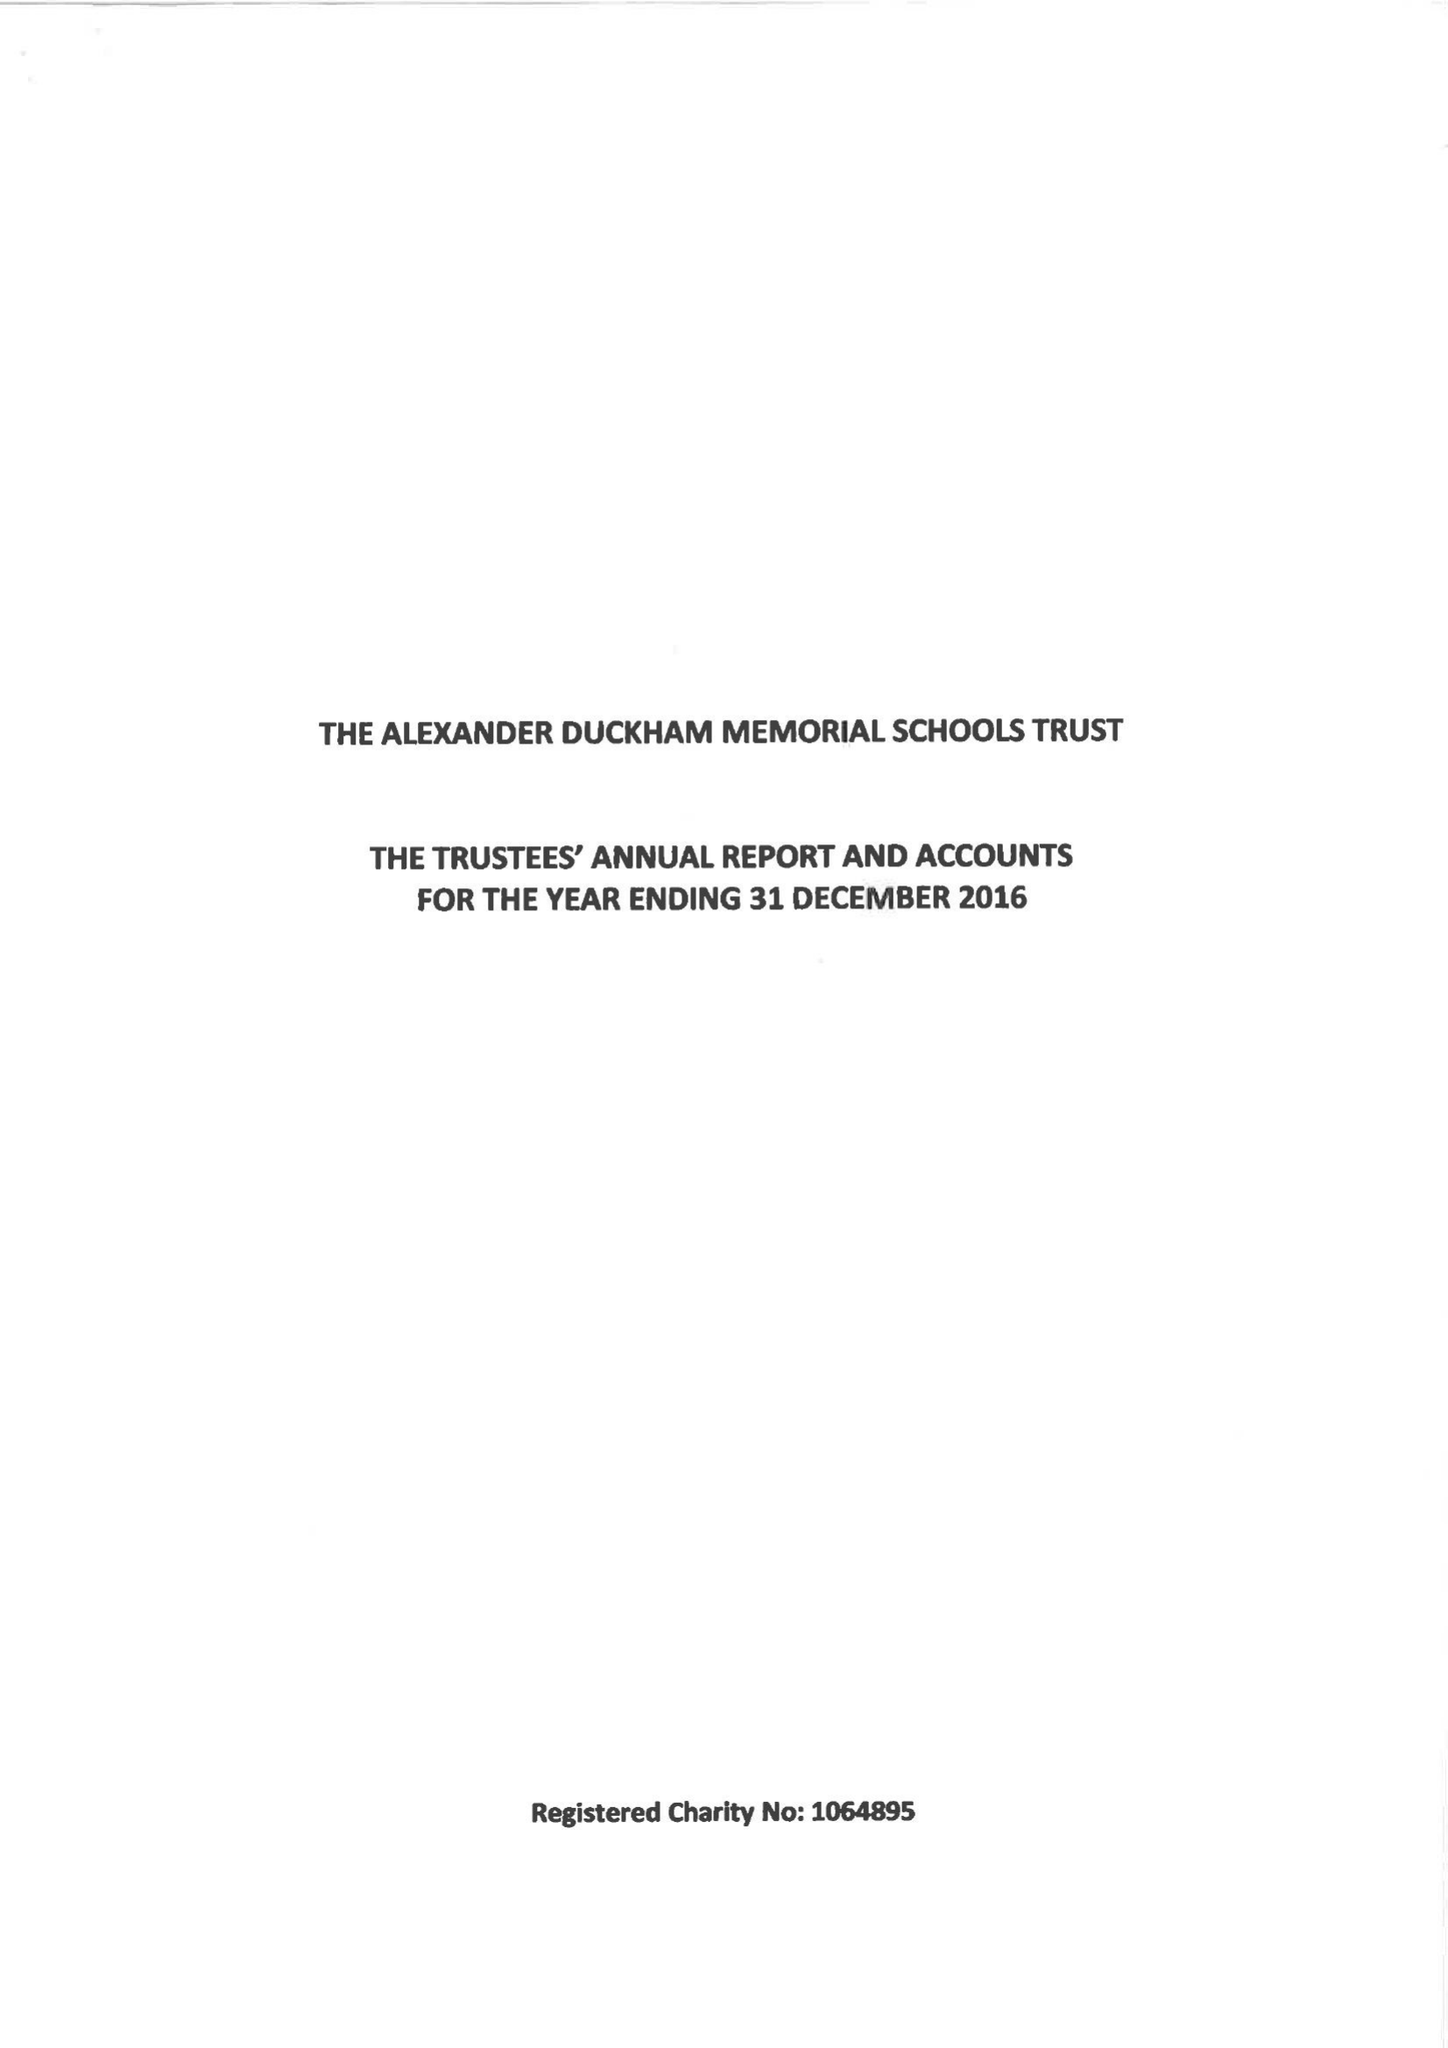What is the value for the charity_name?
Answer the question using a single word or phrase. The Alexander Duckham Memorial Schools Trust 